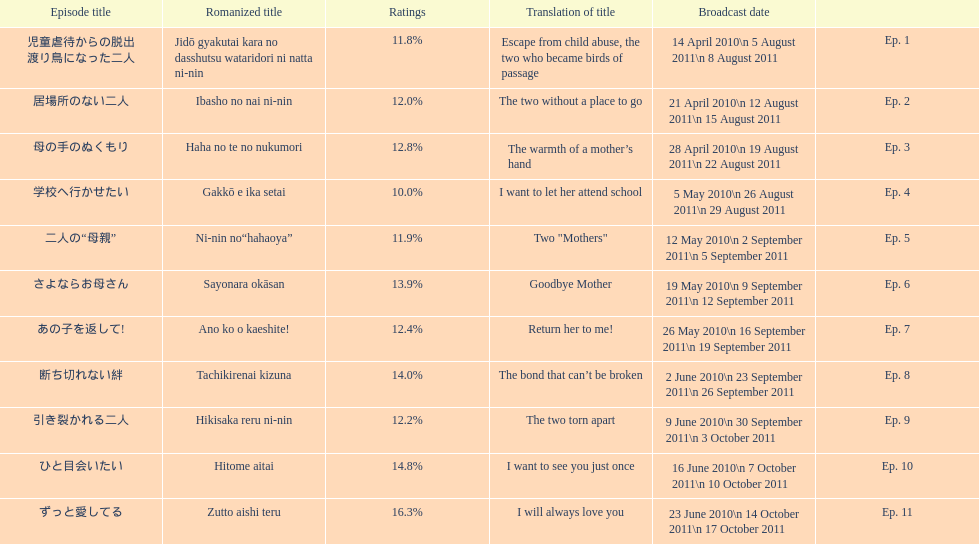What as the percentage total of ratings for episode 8? 14.0%. 